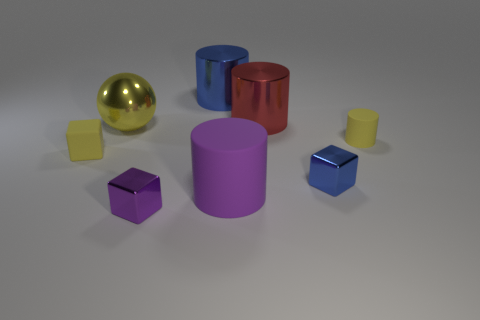Add 1 spheres. How many objects exist? 9 Subtract all blocks. How many objects are left? 5 Add 4 big blue shiny objects. How many big blue shiny objects exist? 5 Subtract 1 yellow cylinders. How many objects are left? 7 Subtract all tiny matte objects. Subtract all purple metallic cubes. How many objects are left? 5 Add 8 big red objects. How many big red objects are left? 9 